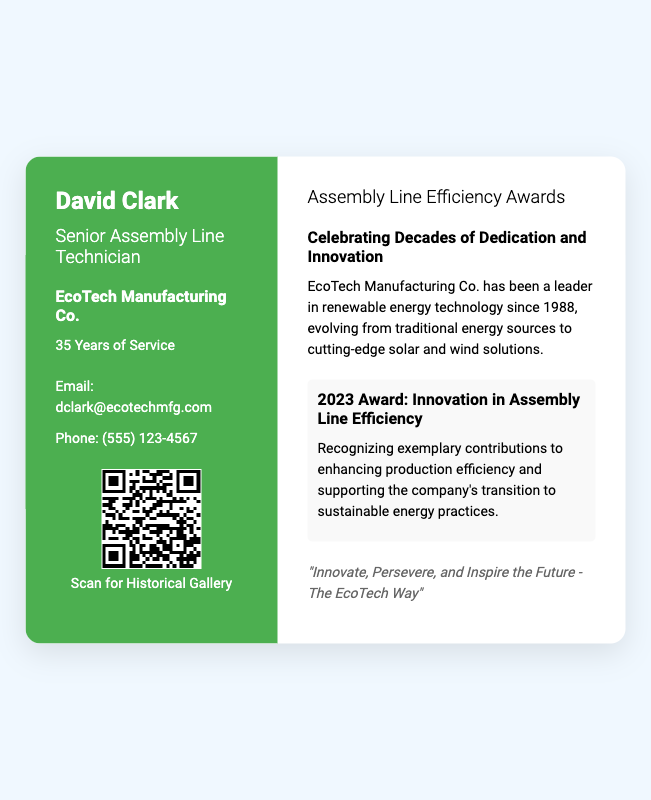What is the name of the senior assembly line technician? The document explicitly states the name of the person as David Clark.
Answer: David Clark What year did EcoTech Manufacturing Co. start? The document mentions that the company has been a leader in renewable energy technology since 1988.
Answer: 1988 How many years of service does David Clark have? The document indicates that David Clark has served for 35 years.
Answer: 35 Years What is the title of the 2023 award mentioned? The document specifies the award title as "Innovation in Assembly Line Efficiency."
Answer: Innovation in Assembly Line Efficiency What company is this business card associated with? The document clearly states that the card belongs to EcoTech Manufacturing Co.
Answer: EcoTech Manufacturing Co Why is the 2023 award significant? The document explains that it recognizes exemplary contributions to enhancing production efficiency and supporting the company's transition to sustainable energy practices.
Answer: Enhancing production efficiency What does the QR code link to? The document indicates that scanning the QR code leads to EcoTech Manufacturing Co.'s historical gallery.
Answer: Historical Gallery What phrase encapsulates the company's philosophy? The document provides a quote summarizing the company's philosophy as "Innovate, Persevere, and Inspire the Future - The EcoTech Way."
Answer: Innovate, Persevere, and Inspire the Future - The EcoTech Way What color is the left section of the business card? The document describes the left section as having a background color of green (specifically, #4CAF50).
Answer: Green 